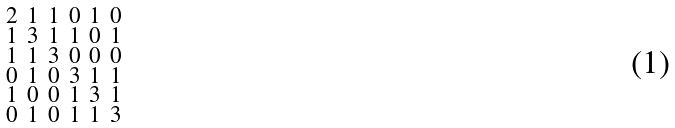Convert formula to latex. <formula><loc_0><loc_0><loc_500><loc_500>\begin{smallmatrix} 2 & 1 & 1 & 0 & 1 & 0 \\ 1 & 3 & 1 & 1 & 0 & 1 \\ 1 & 1 & 3 & 0 & 0 & 0 \\ 0 & 1 & 0 & 3 & 1 & 1 \\ 1 & 0 & 0 & 1 & 3 & 1 \\ 0 & 1 & 0 & 1 & 1 & 3 \end{smallmatrix}</formula> 